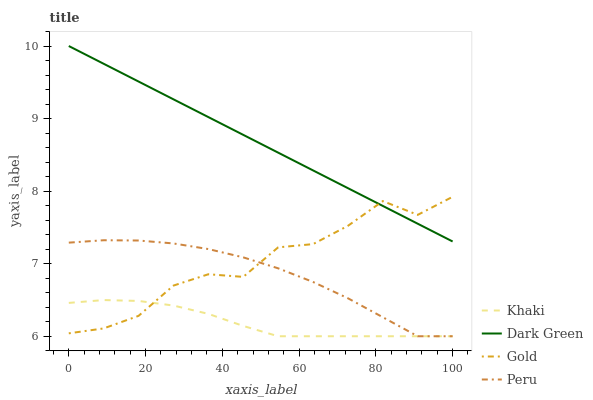Does Khaki have the minimum area under the curve?
Answer yes or no. Yes. Does Dark Green have the maximum area under the curve?
Answer yes or no. Yes. Does Peru have the minimum area under the curve?
Answer yes or no. No. Does Peru have the maximum area under the curve?
Answer yes or no. No. Is Dark Green the smoothest?
Answer yes or no. Yes. Is Gold the roughest?
Answer yes or no. Yes. Is Peru the smoothest?
Answer yes or no. No. Is Peru the roughest?
Answer yes or no. No. Does Khaki have the lowest value?
Answer yes or no. Yes. Does Gold have the lowest value?
Answer yes or no. No. Does Dark Green have the highest value?
Answer yes or no. Yes. Does Peru have the highest value?
Answer yes or no. No. Is Khaki less than Dark Green?
Answer yes or no. Yes. Is Dark Green greater than Khaki?
Answer yes or no. Yes. Does Peru intersect Khaki?
Answer yes or no. Yes. Is Peru less than Khaki?
Answer yes or no. No. Is Peru greater than Khaki?
Answer yes or no. No. Does Khaki intersect Dark Green?
Answer yes or no. No. 